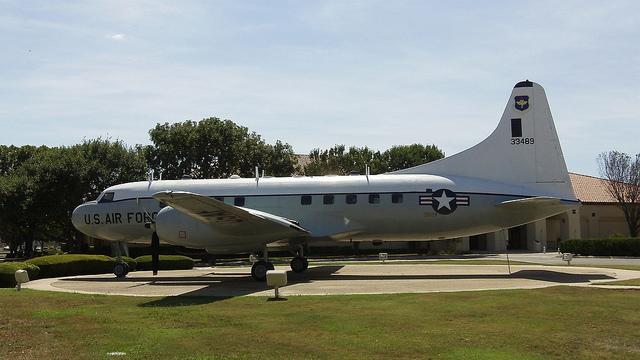Did this plane crash?
Write a very short answer. No. Is this a Russian plane?
Write a very short answer. No. Is this airplane on display?
Concise answer only. Yes. Is this a passenger plane?
Give a very brief answer. No. 